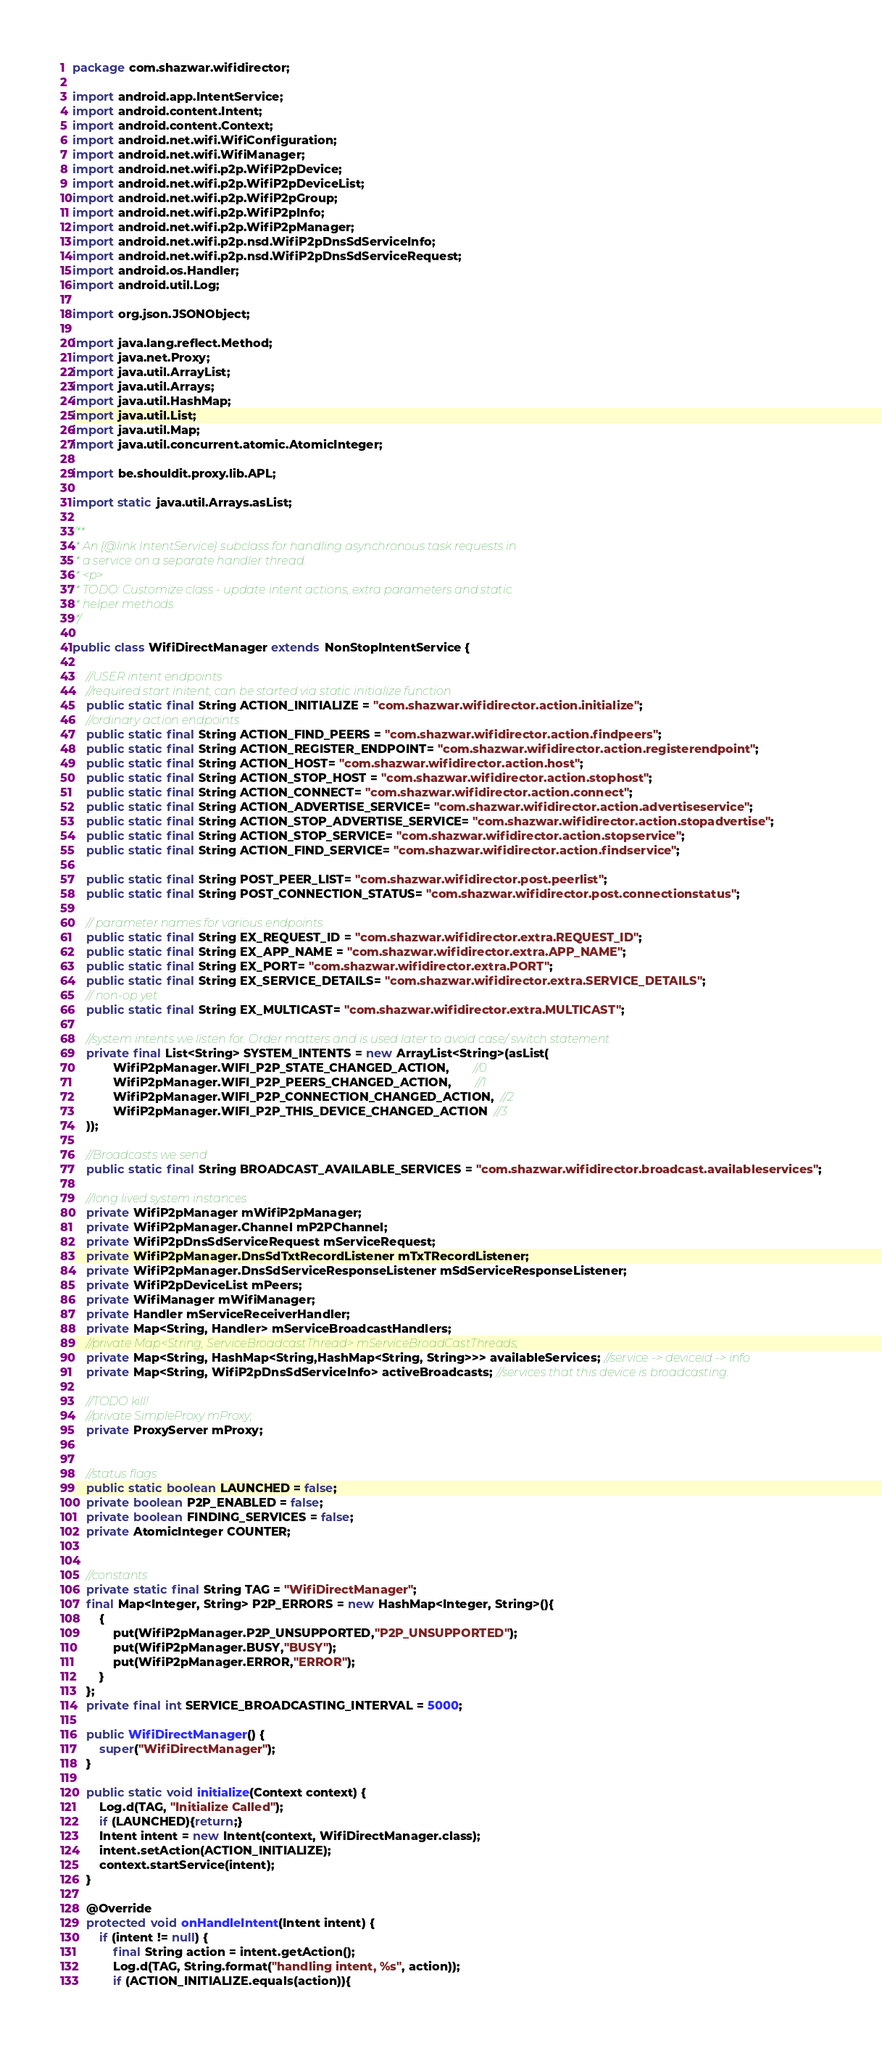Convert code to text. <code><loc_0><loc_0><loc_500><loc_500><_Java_>package com.shazwar.wifidirector;

import android.app.IntentService;
import android.content.Intent;
import android.content.Context;
import android.net.wifi.WifiConfiguration;
import android.net.wifi.WifiManager;
import android.net.wifi.p2p.WifiP2pDevice;
import android.net.wifi.p2p.WifiP2pDeviceList;
import android.net.wifi.p2p.WifiP2pGroup;
import android.net.wifi.p2p.WifiP2pInfo;
import android.net.wifi.p2p.WifiP2pManager;
import android.net.wifi.p2p.nsd.WifiP2pDnsSdServiceInfo;
import android.net.wifi.p2p.nsd.WifiP2pDnsSdServiceRequest;
import android.os.Handler;
import android.util.Log;

import org.json.JSONObject;

import java.lang.reflect.Method;
import java.net.Proxy;
import java.util.ArrayList;
import java.util.Arrays;
import java.util.HashMap;
import java.util.List;
import java.util.Map;
import java.util.concurrent.atomic.AtomicInteger;

import be.shouldit.proxy.lib.APL;

import static java.util.Arrays.asList;

/**
 * An {@link IntentService} subclass for handling asynchronous task requests in
 * a service on a separate handler thread.
 * <p>
 * TODO: Customize class - update intent actions, extra parameters and static
 * helper methods.
 */

public class WifiDirectManager extends NonStopIntentService {

    //USER intent endpoints
    //required start initent, can be started via static initialize function
    public static final String ACTION_INITIALIZE = "com.shazwar.wifidirector.action.initialize";
    //ordinary action endpoints
    public static final String ACTION_FIND_PEERS = "com.shazwar.wifidirector.action.findpeers";
    public static final String ACTION_REGISTER_ENDPOINT= "com.shazwar.wifidirector.action.registerendpoint";
    public static final String ACTION_HOST= "com.shazwar.wifidirector.action.host";
    public static final String ACTION_STOP_HOST = "com.shazwar.wifidirector.action.stophost";
    public static final String ACTION_CONNECT= "com.shazwar.wifidirector.action.connect";
    public static final String ACTION_ADVERTISE_SERVICE= "com.shazwar.wifidirector.action.advertiseservice";
    public static final String ACTION_STOP_ADVERTISE_SERVICE= "com.shazwar.wifidirector.action.stopadvertise";
    public static final String ACTION_STOP_SERVICE= "com.shazwar.wifidirector.action.stopservice";
    public static final String ACTION_FIND_SERVICE= "com.shazwar.wifidirector.action.findservice";

    public static final String POST_PEER_LIST= "com.shazwar.wifidirector.post.peerlist";
    public static final String POST_CONNECTION_STATUS= "com.shazwar.wifidirector.post.connectionstatus";

    // parameter names for various endpoints
    public static final String EX_REQUEST_ID = "com.shazwar.wifidirector.extra.REQUEST_ID";
    public static final String EX_APP_NAME = "com.shazwar.wifidirector.extra.APP_NAME";
    public static final String EX_PORT= "com.shazwar.wifidirector.extra.PORT";
    public static final String EX_SERVICE_DETAILS= "com.shazwar.wifidirector.extra.SERVICE_DETAILS";
    // non-op yet
    public static final String EX_MULTICAST= "com.shazwar.wifidirector.extra.MULTICAST";

    //system intents we listen for. Order matters and is used later to avoid case/ switch statement
    private final List<String> SYSTEM_INTENTS = new ArrayList<String>(asList(
            WifiP2pManager.WIFI_P2P_STATE_CHANGED_ACTION,       //0
            WifiP2pManager.WIFI_P2P_PEERS_CHANGED_ACTION,       //1
            WifiP2pManager.WIFI_P2P_CONNECTION_CHANGED_ACTION,  //2
            WifiP2pManager.WIFI_P2P_THIS_DEVICE_CHANGED_ACTION  //3
    ));

    //Broadcasts we send
    public static final String BROADCAST_AVAILABLE_SERVICES = "com.shazwar.wifidirector.broadcast.availableservices";

    //long lived system instances
    private WifiP2pManager mWifiP2pManager;
    private WifiP2pManager.Channel mP2PChannel;
    private WifiP2pDnsSdServiceRequest mServiceRequest;
    private WifiP2pManager.DnsSdTxtRecordListener mTxTRecordListener;
    private WifiP2pManager.DnsSdServiceResponseListener mSdServiceResponseListener;
    private WifiP2pDeviceList mPeers;
    private WifiManager mWifiManager;
    private Handler mServiceReceiverHandler;
    private Map<String, Handler> mServiceBroadcastHandlers;
    //private Map<String, ServiceBroadcastThread> mServiceBroadCastThreads;
    private Map<String, HashMap<String,HashMap<String, String>>> availableServices; //service -> deviceid -> info
    private Map<String, WifiP2pDnsSdServiceInfo> activeBroadcasts; //services that this device is broadcasting.

    //TODO kill!
    //private SimpleProxy mProxy;
    private ProxyServer mProxy;


    //status flags
    public static boolean LAUNCHED = false;
    private boolean P2P_ENABLED = false;
    private boolean FINDING_SERVICES = false;
    private AtomicInteger COUNTER;


    //constants
    private static final String TAG = "WifiDirectManager";
    final Map<Integer, String> P2P_ERRORS = new HashMap<Integer, String>(){
        {
            put(WifiP2pManager.P2P_UNSUPPORTED,"P2P_UNSUPPORTED");
            put(WifiP2pManager.BUSY,"BUSY");
            put(WifiP2pManager.ERROR,"ERROR");
        }
    };
    private final int SERVICE_BROADCASTING_INTERVAL = 5000;

    public WifiDirectManager() {
        super("WifiDirectManager");
    }

    public static void initialize(Context context) {
        Log.d(TAG, "Initialize Called");
        if (LAUNCHED){return;}
        Intent intent = new Intent(context, WifiDirectManager.class);
        intent.setAction(ACTION_INITIALIZE);
        context.startService(intent);
    }

    @Override
    protected void onHandleIntent(Intent intent) {
        if (intent != null) {
            final String action = intent.getAction();
            Log.d(TAG, String.format("handling intent, %s", action));
            if (ACTION_INITIALIZE.equals(action)){</code> 